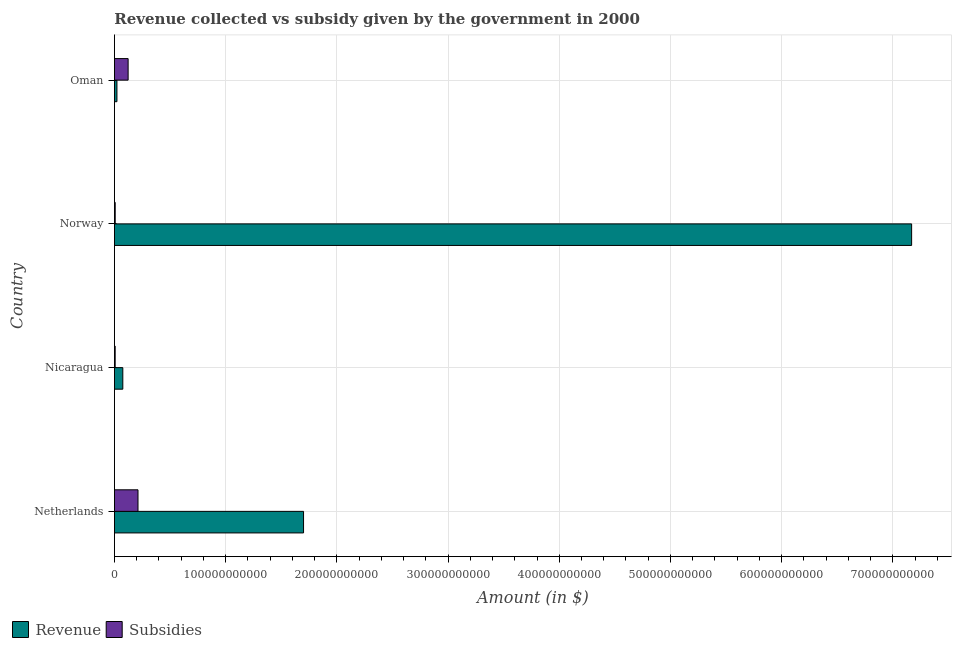Are the number of bars per tick equal to the number of legend labels?
Ensure brevity in your answer.  Yes. How many bars are there on the 2nd tick from the top?
Offer a very short reply. 2. How many bars are there on the 1st tick from the bottom?
Give a very brief answer. 2. What is the label of the 1st group of bars from the top?
Your response must be concise. Oman. In how many cases, is the number of bars for a given country not equal to the number of legend labels?
Provide a short and direct response. 0. What is the amount of subsidies given in Nicaragua?
Provide a succinct answer. 6.65e+08. Across all countries, what is the maximum amount of subsidies given?
Your answer should be very brief. 2.12e+1. Across all countries, what is the minimum amount of revenue collected?
Your answer should be very brief. 2.25e+09. In which country was the amount of revenue collected minimum?
Give a very brief answer. Oman. What is the total amount of revenue collected in the graph?
Provide a succinct answer. 8.97e+11. What is the difference between the amount of subsidies given in Netherlands and that in Oman?
Keep it short and to the point. 8.88e+09. What is the difference between the amount of subsidies given in Norway and the amount of revenue collected in Oman?
Your answer should be compact. -1.55e+09. What is the average amount of subsidies given per country?
Offer a very short reply. 8.72e+09. What is the difference between the amount of revenue collected and amount of subsidies given in Norway?
Give a very brief answer. 7.16e+11. What is the ratio of the amount of subsidies given in Netherlands to that in Oman?
Keep it short and to the point. 1.72. What is the difference between the highest and the second highest amount of subsidies given?
Your response must be concise. 8.88e+09. What is the difference between the highest and the lowest amount of revenue collected?
Keep it short and to the point. 7.15e+11. Is the sum of the amount of subsidies given in Nicaragua and Norway greater than the maximum amount of revenue collected across all countries?
Give a very brief answer. No. What does the 2nd bar from the top in Oman represents?
Provide a short and direct response. Revenue. What does the 2nd bar from the bottom in Nicaragua represents?
Offer a very short reply. Subsidies. What is the difference between two consecutive major ticks on the X-axis?
Offer a terse response. 1.00e+11. Are the values on the major ticks of X-axis written in scientific E-notation?
Your response must be concise. No. Does the graph contain any zero values?
Offer a terse response. No. Where does the legend appear in the graph?
Offer a terse response. Bottom left. How many legend labels are there?
Provide a succinct answer. 2. What is the title of the graph?
Your response must be concise. Revenue collected vs subsidy given by the government in 2000. What is the label or title of the X-axis?
Your answer should be compact. Amount (in $). What is the label or title of the Y-axis?
Your answer should be very brief. Country. What is the Amount (in $) of Revenue in Netherlands?
Offer a terse response. 1.70e+11. What is the Amount (in $) of Subsidies in Netherlands?
Provide a short and direct response. 2.12e+1. What is the Amount (in $) in Revenue in Nicaragua?
Offer a very short reply. 7.54e+09. What is the Amount (in $) in Subsidies in Nicaragua?
Give a very brief answer. 6.65e+08. What is the Amount (in $) of Revenue in Norway?
Offer a very short reply. 7.17e+11. What is the Amount (in $) of Subsidies in Norway?
Offer a terse response. 7.01e+08. What is the Amount (in $) in Revenue in Oman?
Provide a short and direct response. 2.25e+09. What is the Amount (in $) in Subsidies in Oman?
Provide a succinct answer. 1.23e+1. Across all countries, what is the maximum Amount (in $) in Revenue?
Your answer should be very brief. 7.17e+11. Across all countries, what is the maximum Amount (in $) of Subsidies?
Your answer should be compact. 2.12e+1. Across all countries, what is the minimum Amount (in $) in Revenue?
Your answer should be very brief. 2.25e+09. Across all countries, what is the minimum Amount (in $) of Subsidies?
Your answer should be very brief. 6.65e+08. What is the total Amount (in $) in Revenue in the graph?
Give a very brief answer. 8.97e+11. What is the total Amount (in $) of Subsidies in the graph?
Offer a very short reply. 3.49e+1. What is the difference between the Amount (in $) of Revenue in Netherlands and that in Nicaragua?
Offer a very short reply. 1.63e+11. What is the difference between the Amount (in $) of Subsidies in Netherlands and that in Nicaragua?
Make the answer very short. 2.05e+1. What is the difference between the Amount (in $) of Revenue in Netherlands and that in Norway?
Offer a very short reply. -5.47e+11. What is the difference between the Amount (in $) of Subsidies in Netherlands and that in Norway?
Ensure brevity in your answer.  2.05e+1. What is the difference between the Amount (in $) of Revenue in Netherlands and that in Oman?
Your answer should be very brief. 1.68e+11. What is the difference between the Amount (in $) of Subsidies in Netherlands and that in Oman?
Keep it short and to the point. 8.88e+09. What is the difference between the Amount (in $) in Revenue in Nicaragua and that in Norway?
Keep it short and to the point. -7.09e+11. What is the difference between the Amount (in $) in Subsidies in Nicaragua and that in Norway?
Offer a very short reply. -3.58e+07. What is the difference between the Amount (in $) of Revenue in Nicaragua and that in Oman?
Give a very brief answer. 5.29e+09. What is the difference between the Amount (in $) of Subsidies in Nicaragua and that in Oman?
Make the answer very short. -1.16e+1. What is the difference between the Amount (in $) in Revenue in Norway and that in Oman?
Offer a very short reply. 7.15e+11. What is the difference between the Amount (in $) in Subsidies in Norway and that in Oman?
Make the answer very short. -1.16e+1. What is the difference between the Amount (in $) in Revenue in Netherlands and the Amount (in $) in Subsidies in Nicaragua?
Provide a short and direct response. 1.69e+11. What is the difference between the Amount (in $) in Revenue in Netherlands and the Amount (in $) in Subsidies in Norway?
Give a very brief answer. 1.69e+11. What is the difference between the Amount (in $) of Revenue in Netherlands and the Amount (in $) of Subsidies in Oman?
Make the answer very short. 1.58e+11. What is the difference between the Amount (in $) of Revenue in Nicaragua and the Amount (in $) of Subsidies in Norway?
Provide a succinct answer. 6.84e+09. What is the difference between the Amount (in $) of Revenue in Nicaragua and the Amount (in $) of Subsidies in Oman?
Give a very brief answer. -4.78e+09. What is the difference between the Amount (in $) in Revenue in Norway and the Amount (in $) in Subsidies in Oman?
Make the answer very short. 7.05e+11. What is the average Amount (in $) in Revenue per country?
Offer a terse response. 2.24e+11. What is the average Amount (in $) in Subsidies per country?
Keep it short and to the point. 8.72e+09. What is the difference between the Amount (in $) in Revenue and Amount (in $) in Subsidies in Netherlands?
Provide a succinct answer. 1.49e+11. What is the difference between the Amount (in $) of Revenue and Amount (in $) of Subsidies in Nicaragua?
Your answer should be very brief. 6.87e+09. What is the difference between the Amount (in $) of Revenue and Amount (in $) of Subsidies in Norway?
Offer a terse response. 7.16e+11. What is the difference between the Amount (in $) of Revenue and Amount (in $) of Subsidies in Oman?
Your answer should be very brief. -1.01e+1. What is the ratio of the Amount (in $) in Revenue in Netherlands to that in Nicaragua?
Ensure brevity in your answer.  22.56. What is the ratio of the Amount (in $) of Subsidies in Netherlands to that in Nicaragua?
Provide a succinct answer. 31.88. What is the ratio of the Amount (in $) of Revenue in Netherlands to that in Norway?
Make the answer very short. 0.24. What is the ratio of the Amount (in $) of Subsidies in Netherlands to that in Norway?
Provide a succinct answer. 30.25. What is the ratio of the Amount (in $) in Revenue in Netherlands to that in Oman?
Your answer should be very brief. 75.59. What is the ratio of the Amount (in $) in Subsidies in Netherlands to that in Oman?
Your answer should be very brief. 1.72. What is the ratio of the Amount (in $) in Revenue in Nicaragua to that in Norway?
Provide a short and direct response. 0.01. What is the ratio of the Amount (in $) in Subsidies in Nicaragua to that in Norway?
Offer a terse response. 0.95. What is the ratio of the Amount (in $) in Revenue in Nicaragua to that in Oman?
Your answer should be very brief. 3.35. What is the ratio of the Amount (in $) in Subsidies in Nicaragua to that in Oman?
Offer a terse response. 0.05. What is the ratio of the Amount (in $) of Revenue in Norway to that in Oman?
Make the answer very short. 318.65. What is the ratio of the Amount (in $) of Subsidies in Norway to that in Oman?
Your response must be concise. 0.06. What is the difference between the highest and the second highest Amount (in $) of Revenue?
Provide a succinct answer. 5.47e+11. What is the difference between the highest and the second highest Amount (in $) of Subsidies?
Your answer should be compact. 8.88e+09. What is the difference between the highest and the lowest Amount (in $) in Revenue?
Provide a succinct answer. 7.15e+11. What is the difference between the highest and the lowest Amount (in $) of Subsidies?
Your answer should be very brief. 2.05e+1. 